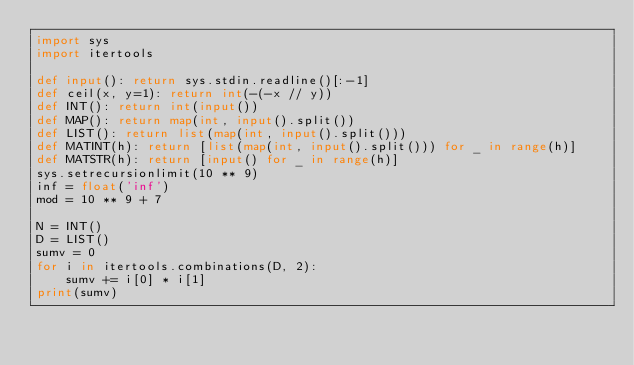Convert code to text. <code><loc_0><loc_0><loc_500><loc_500><_Python_>import sys
import itertools

def input(): return sys.stdin.readline()[:-1]
def ceil(x, y=1): return int(-(-x // y))
def INT(): return int(input())
def MAP(): return map(int, input().split())
def LIST(): return list(map(int, input().split()))
def MATINT(h): return [list(map(int, input().split())) for _ in range(h)]
def MATSTR(h): return [input() for _ in range(h)]
sys.setrecursionlimit(10 ** 9)
inf = float('inf')
mod = 10 ** 9 + 7

N = INT()
D = LIST()
sumv = 0
for i in itertools.combinations(D, 2):
    sumv += i[0] * i[1]
print(sumv)
</code> 